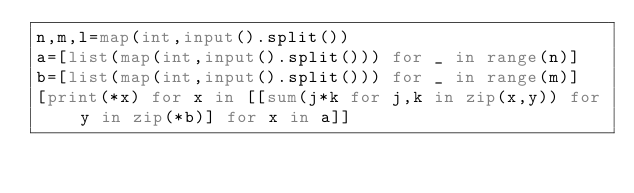Convert code to text. <code><loc_0><loc_0><loc_500><loc_500><_Python_>n,m,l=map(int,input().split())
a=[list(map(int,input().split())) for _ in range(n)]
b=[list(map(int,input().split())) for _ in range(m)]
[print(*x) for x in [[sum(j*k for j,k in zip(x,y)) for y in zip(*b)] for x in a]]
</code> 